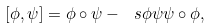Convert formula to latex. <formula><loc_0><loc_0><loc_500><loc_500>[ \phi , \psi ] = \phi \circ \psi - \ s { \phi \psi } \psi \circ \phi ,</formula> 